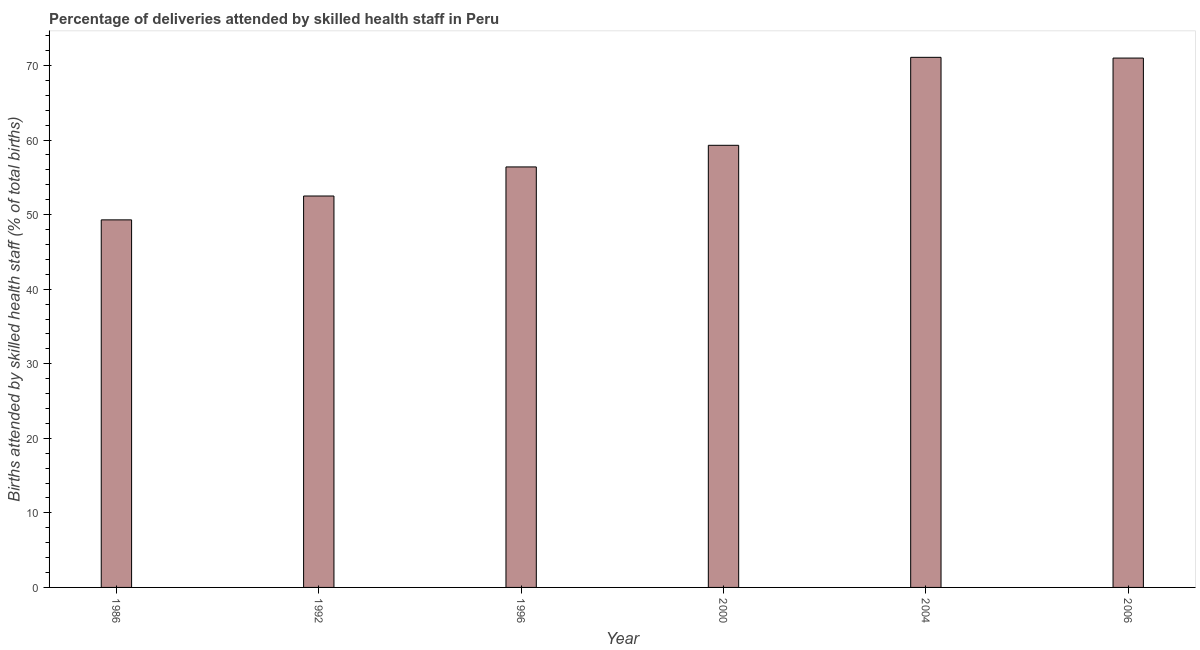Does the graph contain any zero values?
Your response must be concise. No. Does the graph contain grids?
Your answer should be compact. No. What is the title of the graph?
Offer a very short reply. Percentage of deliveries attended by skilled health staff in Peru. What is the label or title of the X-axis?
Provide a succinct answer. Year. What is the label or title of the Y-axis?
Your response must be concise. Births attended by skilled health staff (% of total births). What is the number of births attended by skilled health staff in 1986?
Provide a short and direct response. 49.3. Across all years, what is the maximum number of births attended by skilled health staff?
Your answer should be very brief. 71.1. Across all years, what is the minimum number of births attended by skilled health staff?
Your response must be concise. 49.3. In which year was the number of births attended by skilled health staff minimum?
Provide a short and direct response. 1986. What is the sum of the number of births attended by skilled health staff?
Ensure brevity in your answer.  359.6. What is the difference between the number of births attended by skilled health staff in 1986 and 1992?
Provide a succinct answer. -3.2. What is the average number of births attended by skilled health staff per year?
Your answer should be very brief. 59.93. What is the median number of births attended by skilled health staff?
Provide a succinct answer. 57.85. Do a majority of the years between 1992 and 2004 (inclusive) have number of births attended by skilled health staff greater than 28 %?
Ensure brevity in your answer.  Yes. What is the ratio of the number of births attended by skilled health staff in 1986 to that in 2004?
Your answer should be compact. 0.69. What is the difference between the highest and the lowest number of births attended by skilled health staff?
Make the answer very short. 21.8. How many bars are there?
Your answer should be compact. 6. Are all the bars in the graph horizontal?
Give a very brief answer. No. How many years are there in the graph?
Offer a terse response. 6. Are the values on the major ticks of Y-axis written in scientific E-notation?
Provide a succinct answer. No. What is the Births attended by skilled health staff (% of total births) of 1986?
Your answer should be very brief. 49.3. What is the Births attended by skilled health staff (% of total births) in 1992?
Your answer should be compact. 52.5. What is the Births attended by skilled health staff (% of total births) in 1996?
Keep it short and to the point. 56.4. What is the Births attended by skilled health staff (% of total births) of 2000?
Your answer should be compact. 59.3. What is the Births attended by skilled health staff (% of total births) of 2004?
Provide a short and direct response. 71.1. What is the difference between the Births attended by skilled health staff (% of total births) in 1986 and 1992?
Offer a very short reply. -3.2. What is the difference between the Births attended by skilled health staff (% of total births) in 1986 and 2000?
Your response must be concise. -10. What is the difference between the Births attended by skilled health staff (% of total births) in 1986 and 2004?
Provide a succinct answer. -21.8. What is the difference between the Births attended by skilled health staff (% of total births) in 1986 and 2006?
Ensure brevity in your answer.  -21.7. What is the difference between the Births attended by skilled health staff (% of total births) in 1992 and 2000?
Your answer should be very brief. -6.8. What is the difference between the Births attended by skilled health staff (% of total births) in 1992 and 2004?
Make the answer very short. -18.6. What is the difference between the Births attended by skilled health staff (% of total births) in 1992 and 2006?
Your answer should be very brief. -18.5. What is the difference between the Births attended by skilled health staff (% of total births) in 1996 and 2000?
Your answer should be compact. -2.9. What is the difference between the Births attended by skilled health staff (% of total births) in 1996 and 2004?
Ensure brevity in your answer.  -14.7. What is the difference between the Births attended by skilled health staff (% of total births) in 1996 and 2006?
Provide a short and direct response. -14.6. What is the difference between the Births attended by skilled health staff (% of total births) in 2000 and 2004?
Make the answer very short. -11.8. What is the difference between the Births attended by skilled health staff (% of total births) in 2004 and 2006?
Give a very brief answer. 0.1. What is the ratio of the Births attended by skilled health staff (% of total births) in 1986 to that in 1992?
Provide a short and direct response. 0.94. What is the ratio of the Births attended by skilled health staff (% of total births) in 1986 to that in 1996?
Make the answer very short. 0.87. What is the ratio of the Births attended by skilled health staff (% of total births) in 1986 to that in 2000?
Your answer should be very brief. 0.83. What is the ratio of the Births attended by skilled health staff (% of total births) in 1986 to that in 2004?
Your answer should be very brief. 0.69. What is the ratio of the Births attended by skilled health staff (% of total births) in 1986 to that in 2006?
Offer a very short reply. 0.69. What is the ratio of the Births attended by skilled health staff (% of total births) in 1992 to that in 2000?
Make the answer very short. 0.89. What is the ratio of the Births attended by skilled health staff (% of total births) in 1992 to that in 2004?
Offer a very short reply. 0.74. What is the ratio of the Births attended by skilled health staff (% of total births) in 1992 to that in 2006?
Provide a short and direct response. 0.74. What is the ratio of the Births attended by skilled health staff (% of total births) in 1996 to that in 2000?
Provide a short and direct response. 0.95. What is the ratio of the Births attended by skilled health staff (% of total births) in 1996 to that in 2004?
Your answer should be compact. 0.79. What is the ratio of the Births attended by skilled health staff (% of total births) in 1996 to that in 2006?
Your response must be concise. 0.79. What is the ratio of the Births attended by skilled health staff (% of total births) in 2000 to that in 2004?
Your answer should be compact. 0.83. What is the ratio of the Births attended by skilled health staff (% of total births) in 2000 to that in 2006?
Keep it short and to the point. 0.83. 